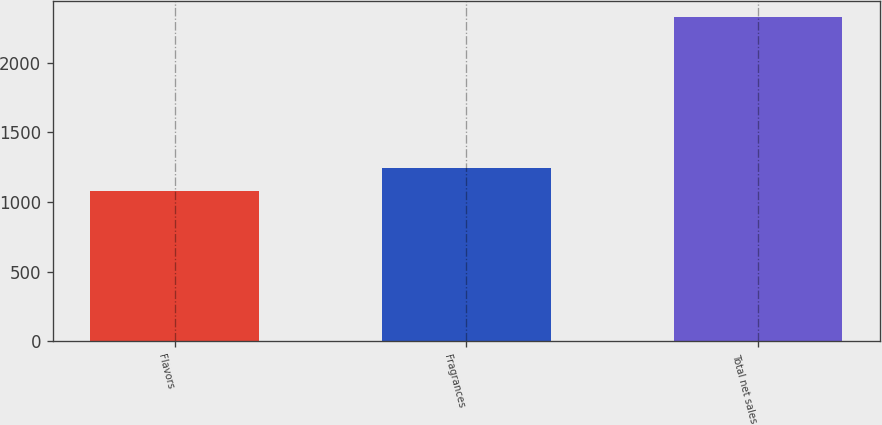<chart> <loc_0><loc_0><loc_500><loc_500><bar_chart><fcel>Flavors<fcel>Fragrances<fcel>Total net sales<nl><fcel>1081<fcel>1245<fcel>2326<nl></chart> 